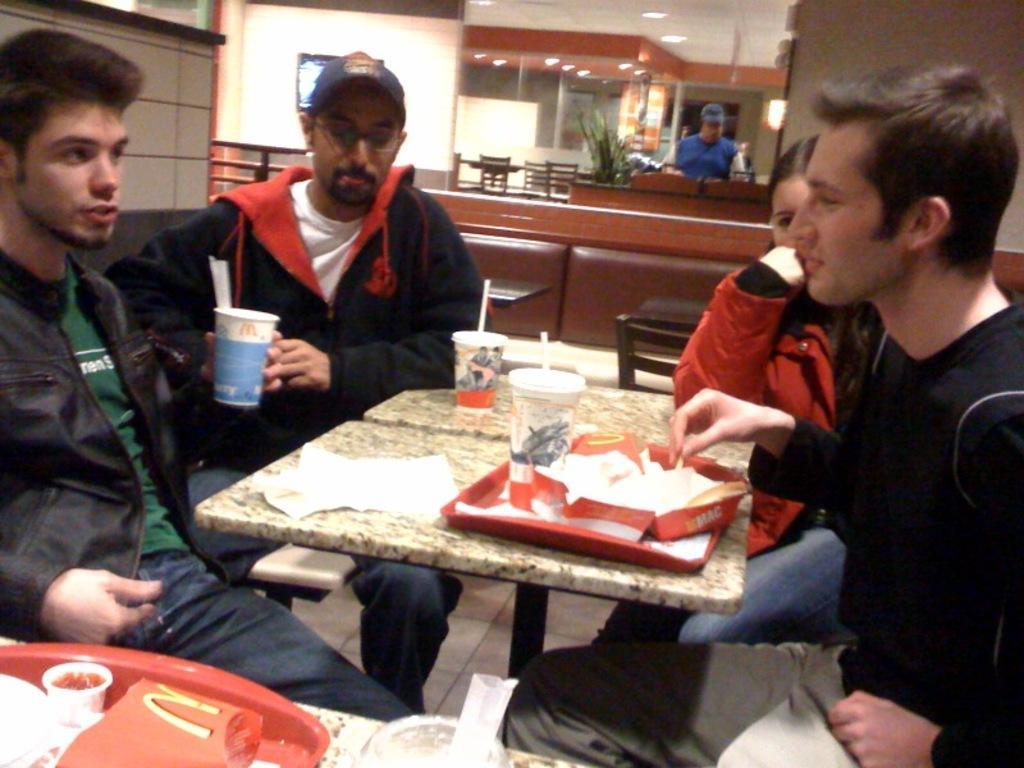Please provide a concise description of this image. in the picture there are four people sitting around the table on the table there are many food items. 